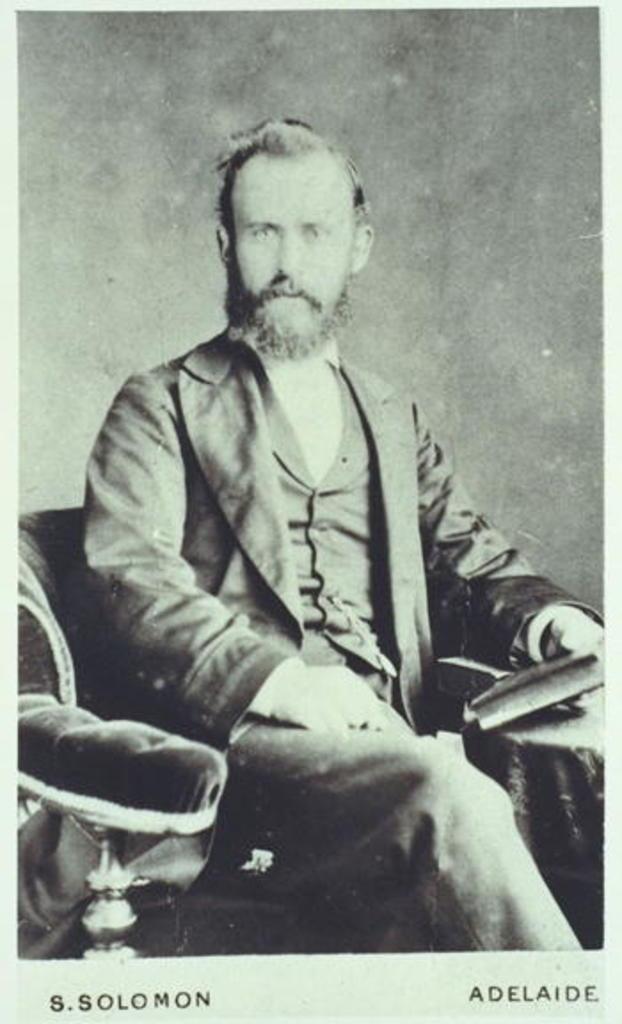Describe this image in one or two sentences. This is a black and white picture. In the middle of the picture, we see a man is sitting on the chair. He is holding a book in his hand. In front of him, we see a table. In the background, it is grey in color. This picture might be taken from the textbook or it might be a photo frame. 